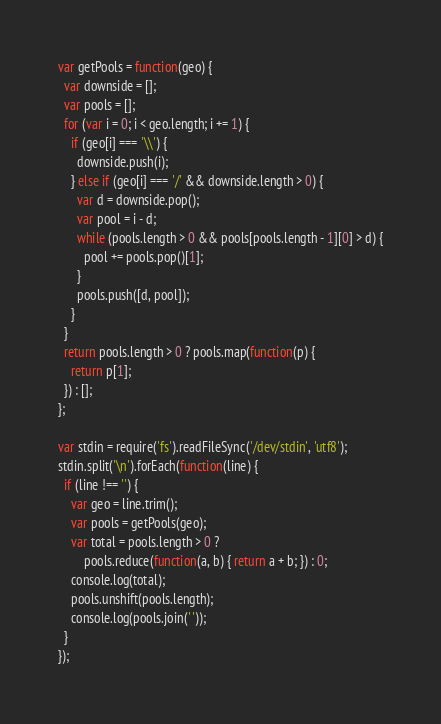Convert code to text. <code><loc_0><loc_0><loc_500><loc_500><_JavaScript_>var getPools = function(geo) {
  var downside = [];
  var pools = [];
  for (var i = 0; i < geo.length; i += 1) {
    if (geo[i] === '\\') {
      downside.push(i);
    } else if (geo[i] === '/' && downside.length > 0) {
      var d = downside.pop();
      var pool = i - d;
      while (pools.length > 0 && pools[pools.length - 1][0] > d) {
        pool += pools.pop()[1];
      }
      pools.push([d, pool]);
    }
  }
  return pools.length > 0 ? pools.map(function(p) {
    return p[1];
  }) : [];
};

var stdin = require('fs').readFileSync('/dev/stdin', 'utf8');
stdin.split('\n').forEach(function(line) {
  if (line !== '') {
    var geo = line.trim();
    var pools = getPools(geo);
    var total = pools.length > 0 ?
        pools.reduce(function(a, b) { return a + b; }) : 0;
    console.log(total);
    pools.unshift(pools.length);
    console.log(pools.join(' '));
  }
});</code> 